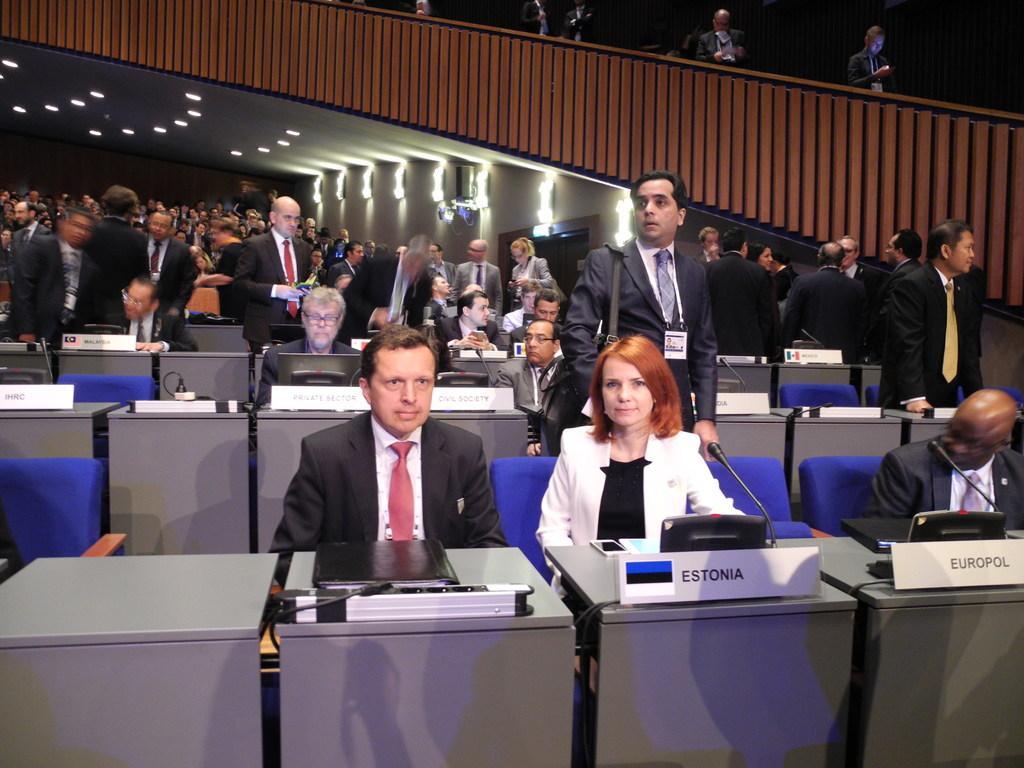In one or two sentences, can you explain what this image depicts? In this image I can see group of people with different color blazers and ties. And I can see few people are standing and few are sitting in-front of the tables. On the tables I can see the mics and the laptops and also the boards. I can see some names written on it. In the back I can see many lights and the brown color railing. In the top I can see few more people. 